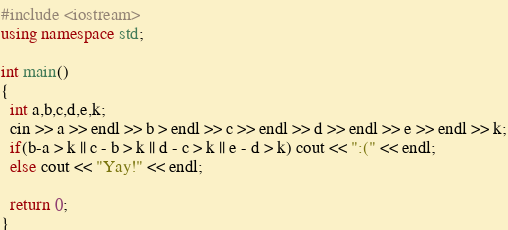<code> <loc_0><loc_0><loc_500><loc_500><_C++_>#include <iostream>
using namespace std;

int main()
{
  int a,b,c,d,e,k;
  cin >> a >> endl >> b > endl >> c >> endl >> d >> endl >> e >> endl >> k;
  if(b-a > k || c - b > k || d - c > k || e - d > k) cout << ":(" << endl;
  else cout << "Yay!" << endl;
  
  return 0;
}</code> 